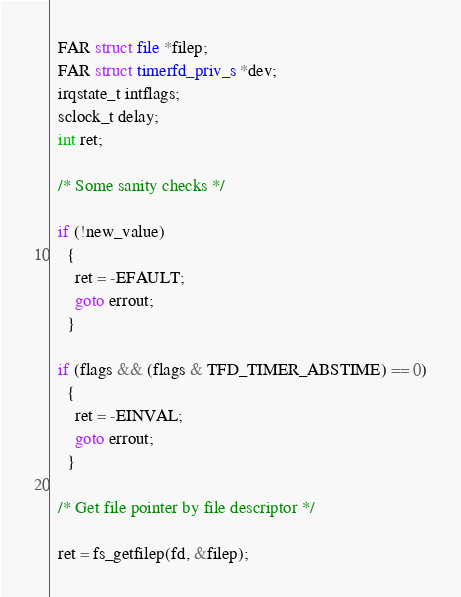Convert code to text. <code><loc_0><loc_0><loc_500><loc_500><_C_>  FAR struct file *filep;
  FAR struct timerfd_priv_s *dev;
  irqstate_t intflags;
  sclock_t delay;
  int ret;

  /* Some sanity checks */

  if (!new_value)
    {
      ret = -EFAULT;
      goto errout;
    }

  if (flags && (flags & TFD_TIMER_ABSTIME) == 0)
    {
      ret = -EINVAL;
      goto errout;
    }

  /* Get file pointer by file descriptor */

  ret = fs_getfilep(fd, &filep);</code> 